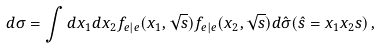Convert formula to latex. <formula><loc_0><loc_0><loc_500><loc_500>d \sigma = \int d x _ { 1 } d x _ { 2 } f _ { e | e } ( x _ { 1 } , \sqrt { s } ) f _ { e | e } ( x _ { 2 } , \sqrt { s } ) d \hat { \sigma } ( \hat { s } = x _ { 1 } x _ { 2 } s ) \, ,</formula> 